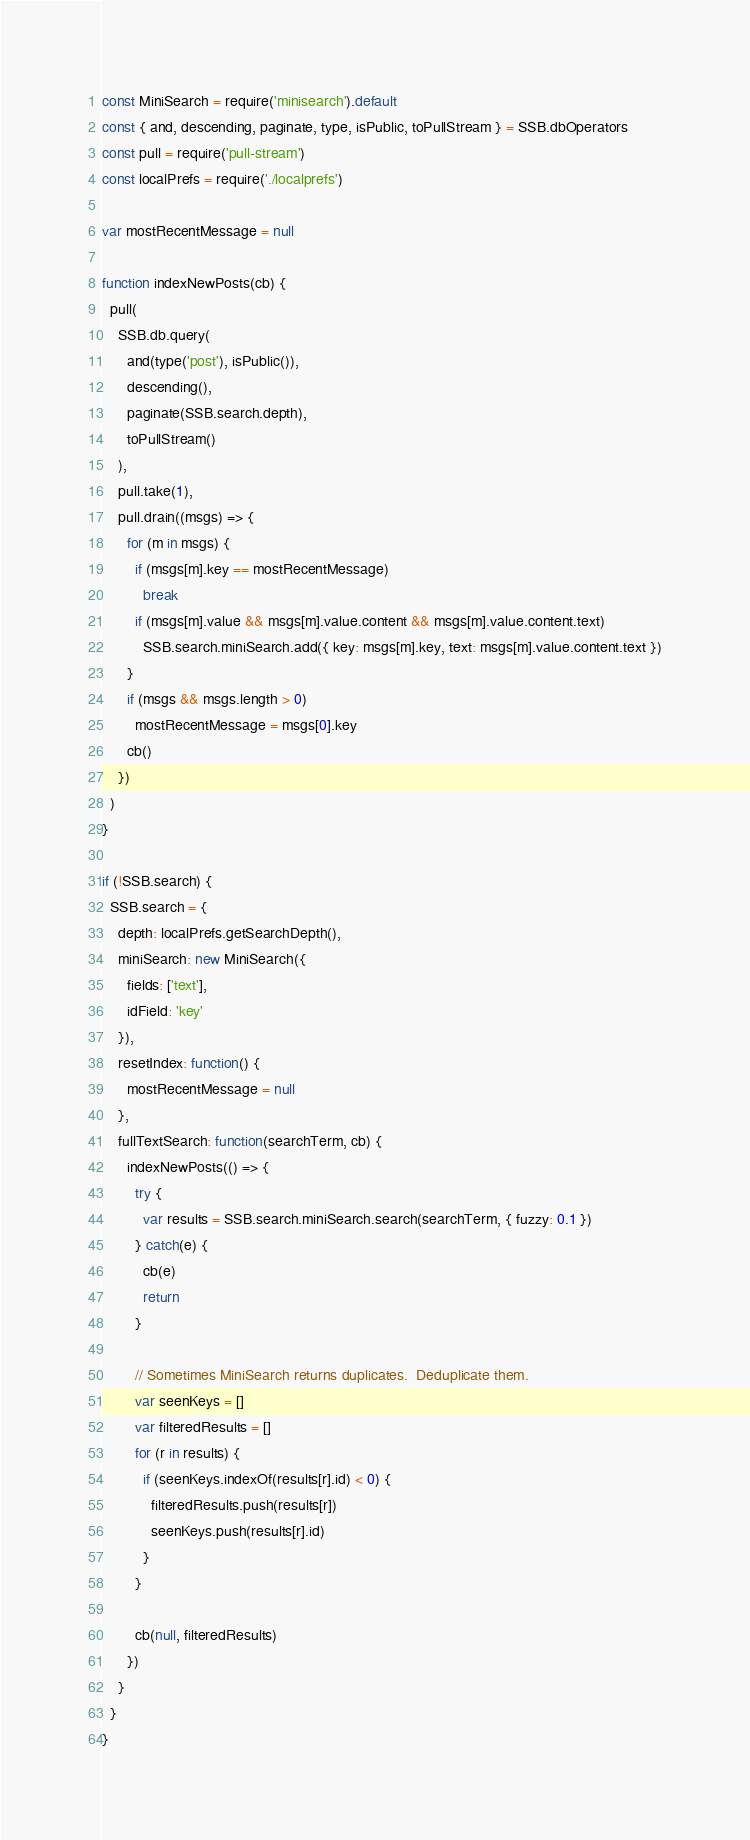Convert code to text. <code><loc_0><loc_0><loc_500><loc_500><_JavaScript_>const MiniSearch = require('minisearch').default
const { and, descending, paginate, type, isPublic, toPullStream } = SSB.dbOperators
const pull = require('pull-stream')
const localPrefs = require('./localprefs')

var mostRecentMessage = null

function indexNewPosts(cb) {
  pull(
    SSB.db.query(
      and(type('post'), isPublic()),
      descending(),
      paginate(SSB.search.depth),
      toPullStream()
    ),
    pull.take(1),
    pull.drain((msgs) => {
      for (m in msgs) {
        if (msgs[m].key == mostRecentMessage)
          break
        if (msgs[m].value && msgs[m].value.content && msgs[m].value.content.text)
          SSB.search.miniSearch.add({ key: msgs[m].key, text: msgs[m].value.content.text })
      }
      if (msgs && msgs.length > 0)
        mostRecentMessage = msgs[0].key
      cb()
    })
  )
}

if (!SSB.search) {
  SSB.search = {
    depth: localPrefs.getSearchDepth(),
    miniSearch: new MiniSearch({
      fields: ['text'],
      idField: 'key'
    }),
    resetIndex: function() {
      mostRecentMessage = null
    },
    fullTextSearch: function(searchTerm, cb) {
      indexNewPosts(() => {
        try {
          var results = SSB.search.miniSearch.search(searchTerm, { fuzzy: 0.1 })
        } catch(e) {
          cb(e)
          return
        }

        // Sometimes MiniSearch returns duplicates.  Deduplicate them.
        var seenKeys = []
        var filteredResults = []
        for (r in results) {
          if (seenKeys.indexOf(results[r].id) < 0) {
            filteredResults.push(results[r])
            seenKeys.push(results[r].id)
          }
        }

        cb(null, filteredResults)
      })
    }
  }
}
</code> 